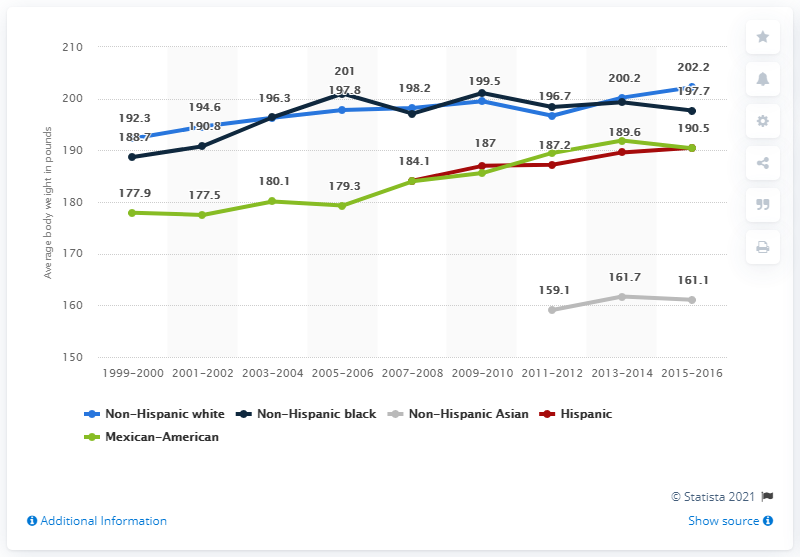Specify some key components in this picture. Non-Hispanic Blacks exceed Non-Hispanic Whites by 3 years. The average body weight for non-Hispanic white men in 1999-2000 was 192.3 pounds. The green color on the label indicates that the product is Mexican-American. 